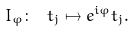Convert formula to latex. <formula><loc_0><loc_0><loc_500><loc_500>I _ { \varphi } \colon \ t _ { j } \mapsto e ^ { i \varphi } t _ { j } .</formula> 